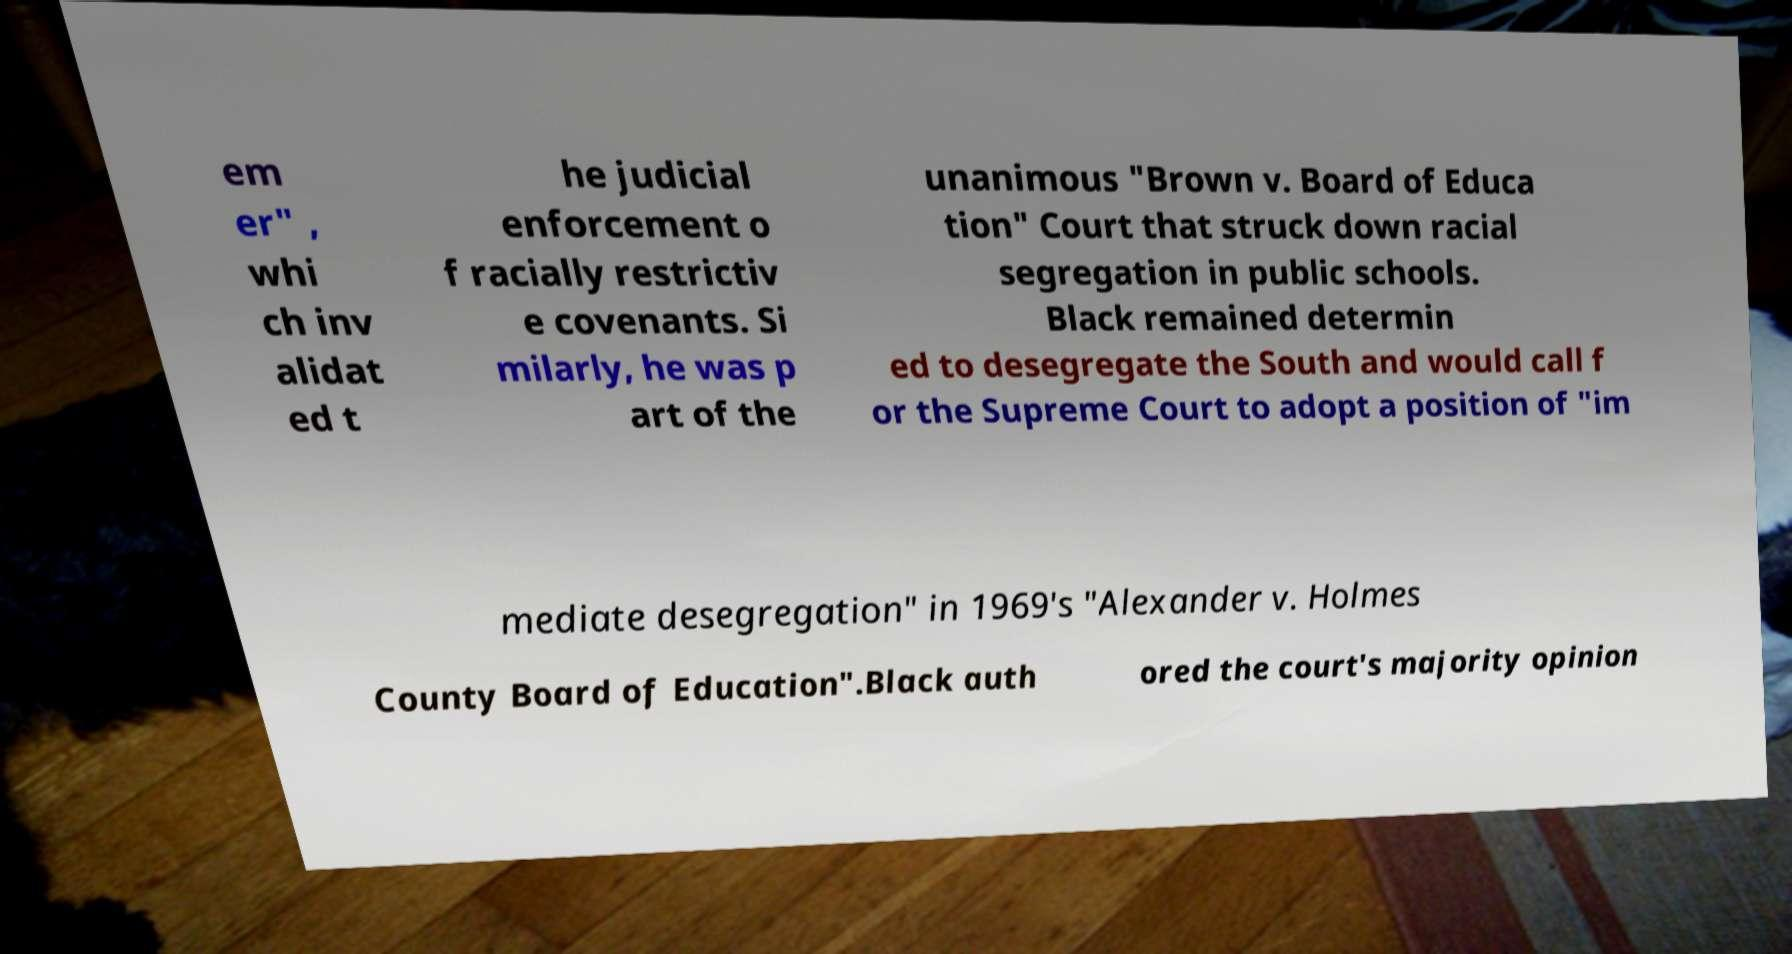Could you assist in decoding the text presented in this image and type it out clearly? em er" , whi ch inv alidat ed t he judicial enforcement o f racially restrictiv e covenants. Si milarly, he was p art of the unanimous "Brown v. Board of Educa tion" Court that struck down racial segregation in public schools. Black remained determin ed to desegregate the South and would call f or the Supreme Court to adopt a position of "im mediate desegregation" in 1969's "Alexander v. Holmes County Board of Education".Black auth ored the court's majority opinion 